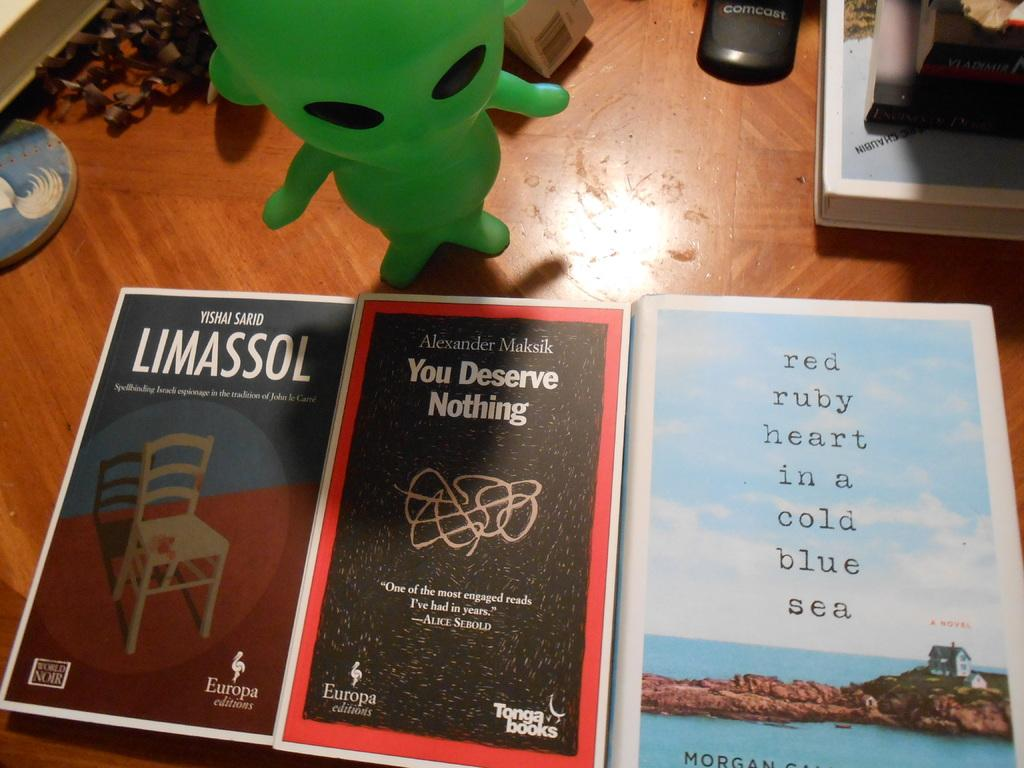<image>
Offer a succinct explanation of the picture presented. Three books are lined up on a table including one titled You Deserve Nothing while a green alien figurine stands by the books. 